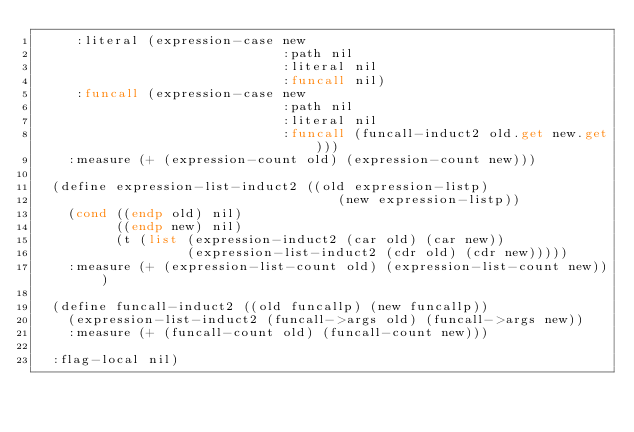<code> <loc_0><loc_0><loc_500><loc_500><_Lisp_>     :literal (expression-case new
                               :path nil
                               :literal nil
                               :funcall nil)
     :funcall (expression-case new
                               :path nil
                               :literal nil
                               :funcall (funcall-induct2 old.get new.get)))
    :measure (+ (expression-count old) (expression-count new)))

  (define expression-list-induct2 ((old expression-listp)
                                      (new expression-listp))
    (cond ((endp old) nil)
          ((endp new) nil)
          (t (list (expression-induct2 (car old) (car new))
                   (expression-list-induct2 (cdr old) (cdr new)))))
    :measure (+ (expression-list-count old) (expression-list-count new)))

  (define funcall-induct2 ((old funcallp) (new funcallp))
    (expression-list-induct2 (funcall->args old) (funcall->args new))
    :measure (+ (funcall-count old) (funcall-count new)))

  :flag-local nil)
</code> 